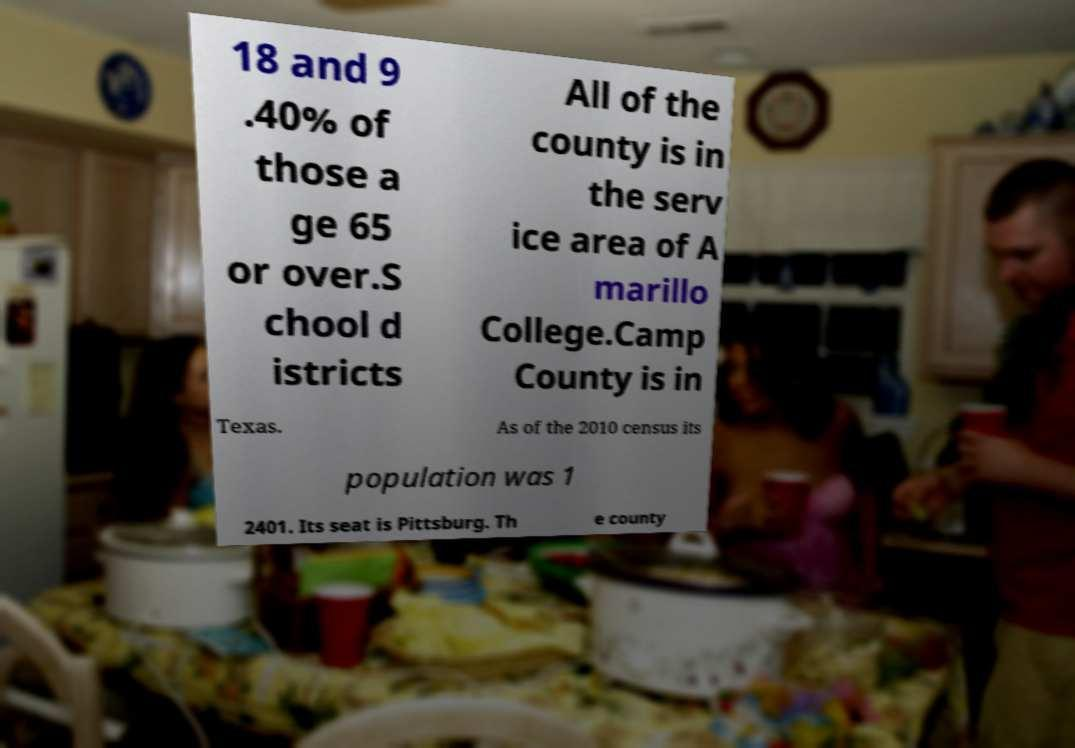I need the written content from this picture converted into text. Can you do that? 18 and 9 .40% of those a ge 65 or over.S chool d istricts All of the county is in the serv ice area of A marillo College.Camp County is in Texas. As of the 2010 census its population was 1 2401. Its seat is Pittsburg. Th e county 